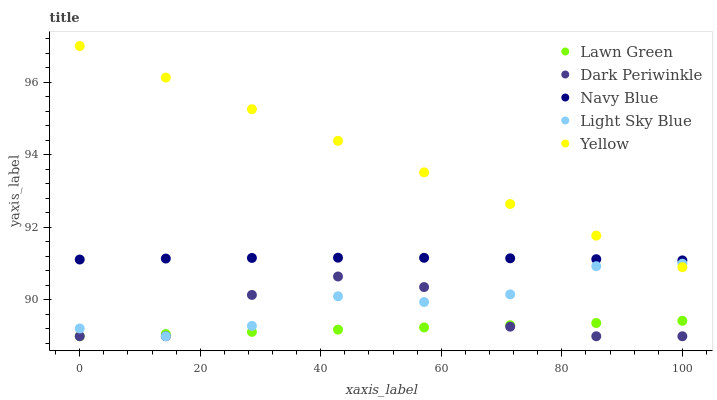Does Lawn Green have the minimum area under the curve?
Answer yes or no. Yes. Does Yellow have the maximum area under the curve?
Answer yes or no. Yes. Does Light Sky Blue have the minimum area under the curve?
Answer yes or no. No. Does Light Sky Blue have the maximum area under the curve?
Answer yes or no. No. Is Lawn Green the smoothest?
Answer yes or no. Yes. Is Dark Periwinkle the roughest?
Answer yes or no. Yes. Is Light Sky Blue the smoothest?
Answer yes or no. No. Is Light Sky Blue the roughest?
Answer yes or no. No. Does Lawn Green have the lowest value?
Answer yes or no. Yes. Does Yellow have the lowest value?
Answer yes or no. No. Does Yellow have the highest value?
Answer yes or no. Yes. Does Light Sky Blue have the highest value?
Answer yes or no. No. Is Light Sky Blue less than Navy Blue?
Answer yes or no. Yes. Is Navy Blue greater than Dark Periwinkle?
Answer yes or no. Yes. Does Light Sky Blue intersect Lawn Green?
Answer yes or no. Yes. Is Light Sky Blue less than Lawn Green?
Answer yes or no. No. Is Light Sky Blue greater than Lawn Green?
Answer yes or no. No. Does Light Sky Blue intersect Navy Blue?
Answer yes or no. No. 